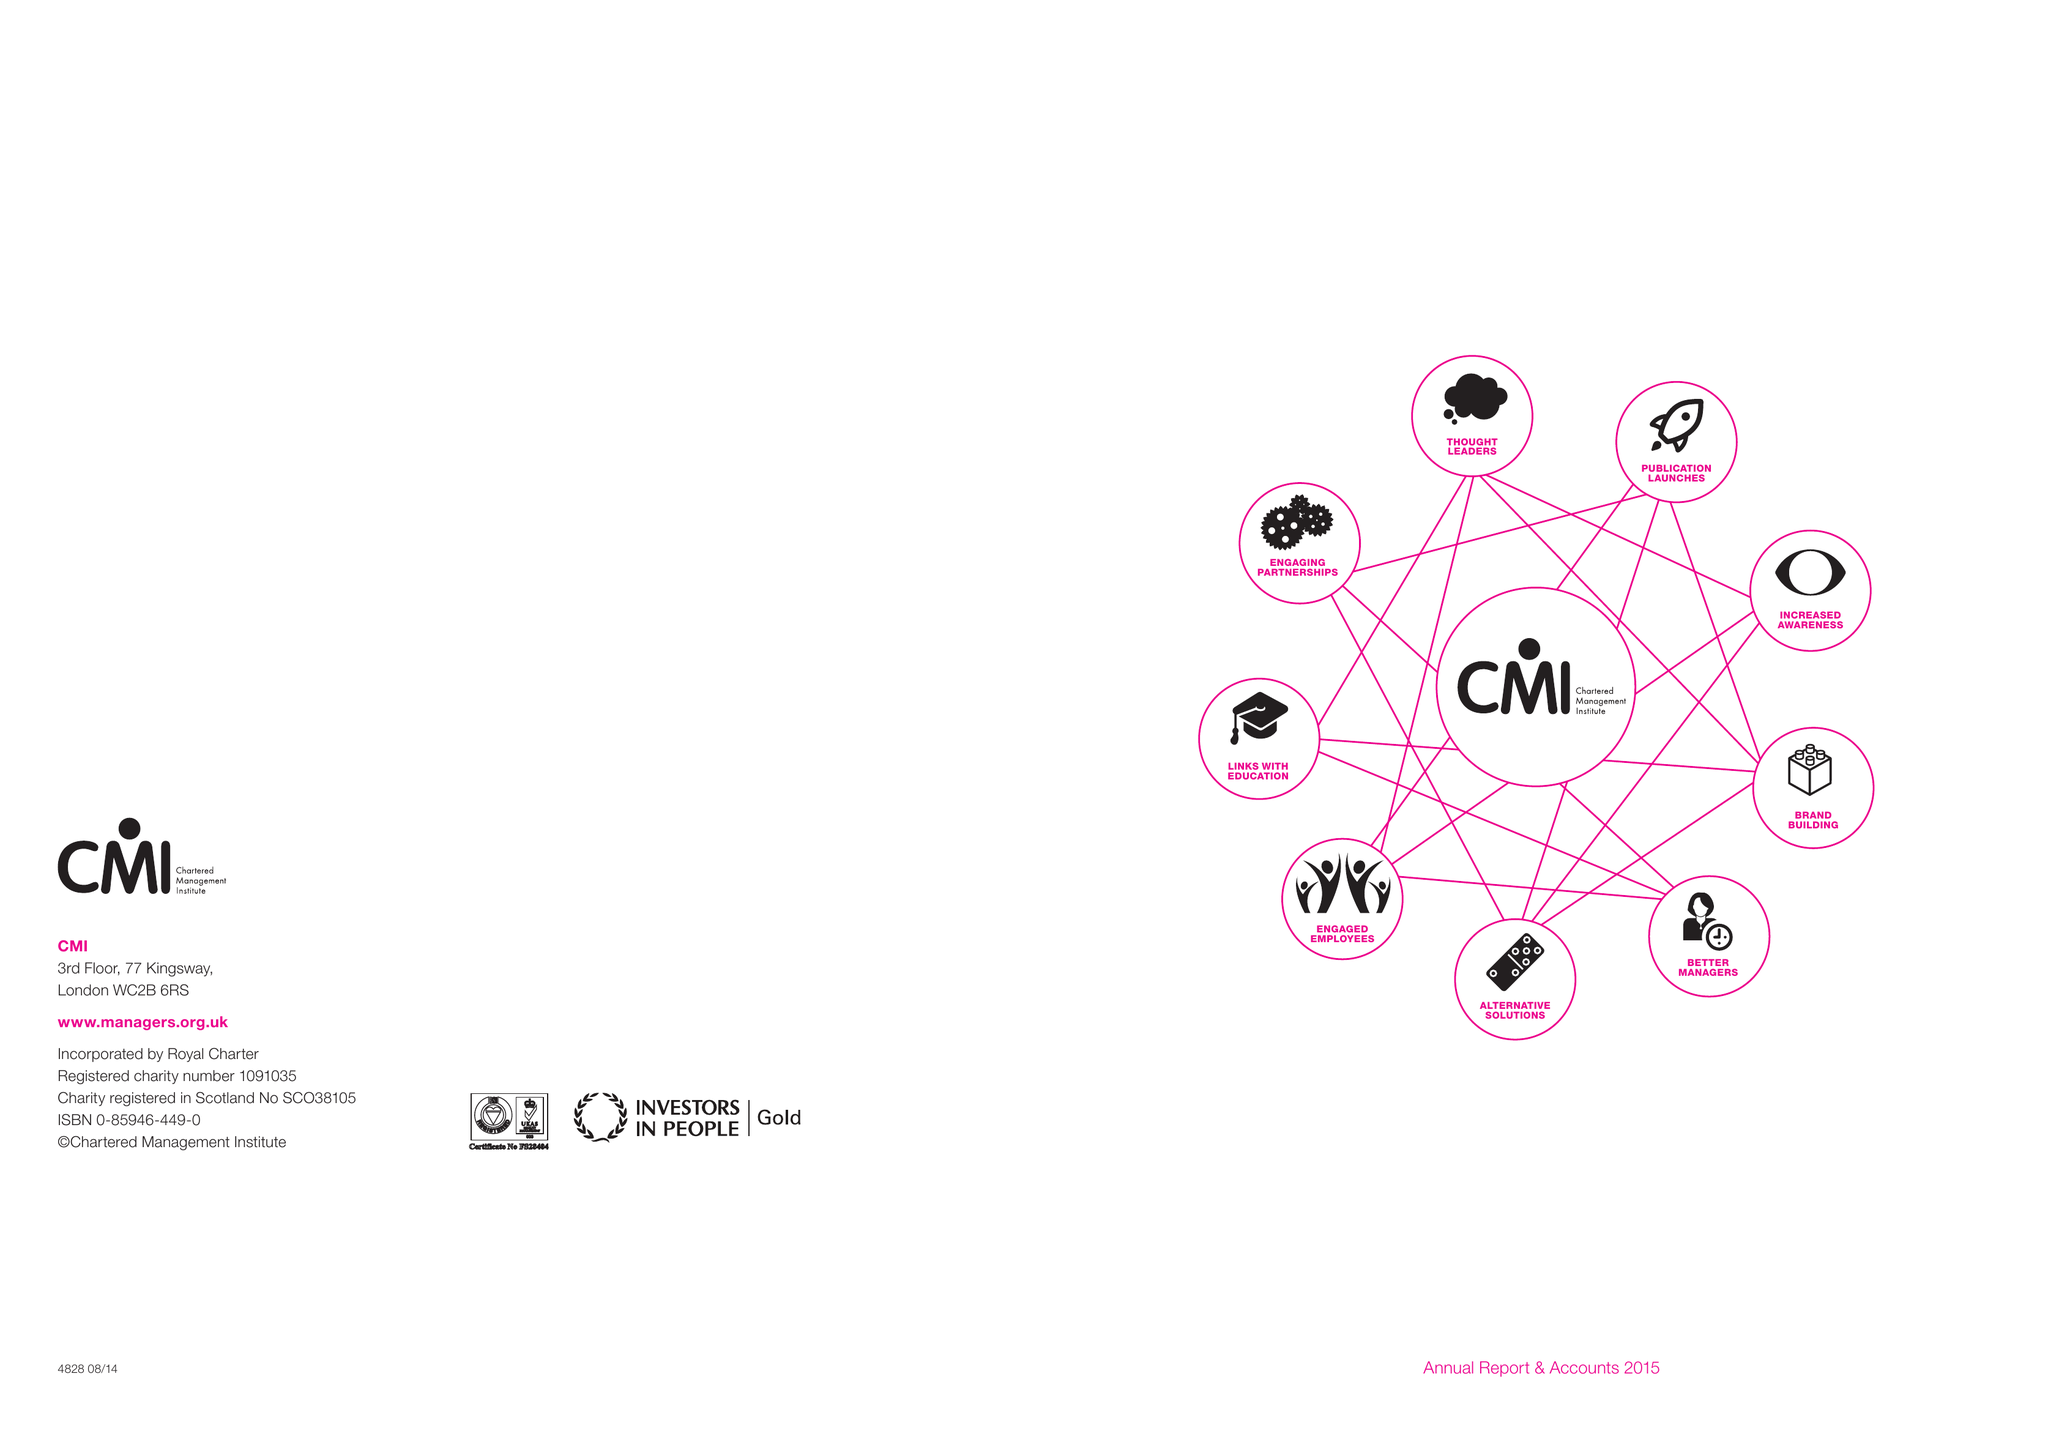What is the value for the report_date?
Answer the question using a single word or phrase. 2015-03-31 